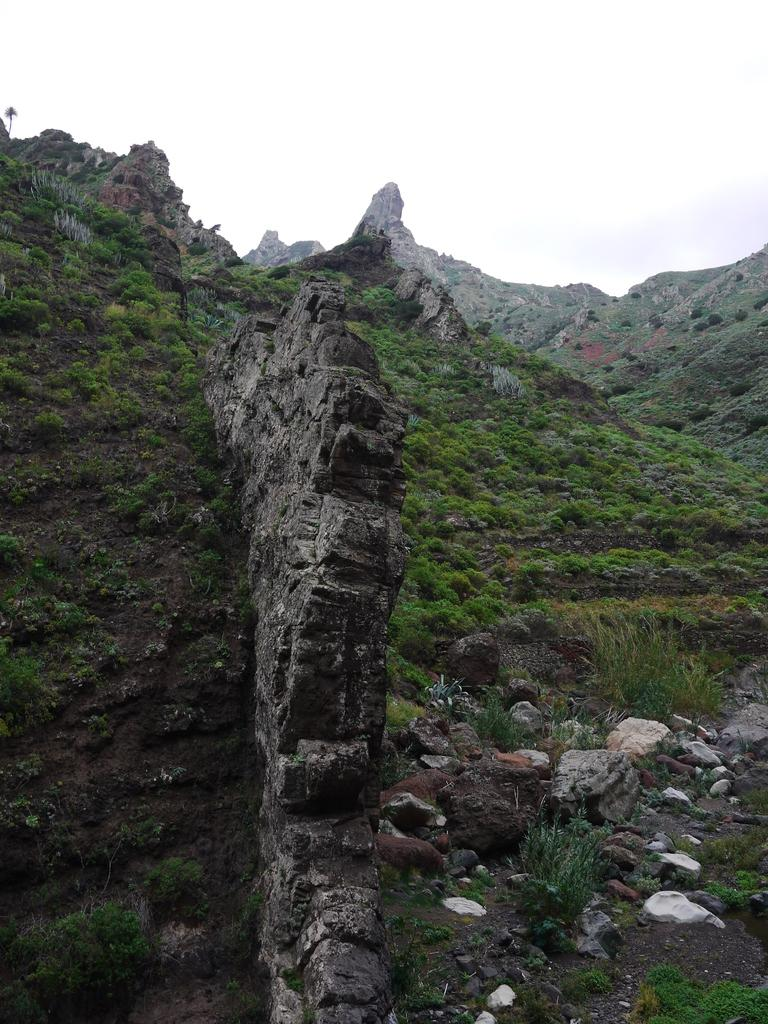What is the main feature in the center of the image? There is a broken wall in the center of the image. What type of vegetation can be seen at the bottom of the image? There is grass on the surface at the bottom of the image. What can be seen in the background of the image? There are rocks and the sky visible in the background of the image. How many dimes are scattered among the rocks in the image? There are no dimes present in the image; it only features a broken wall, grass, rocks, and the sky. What type of fowl can be seen flying in the sky in the image? There are no birds or fowl visible in the sky in the image. 